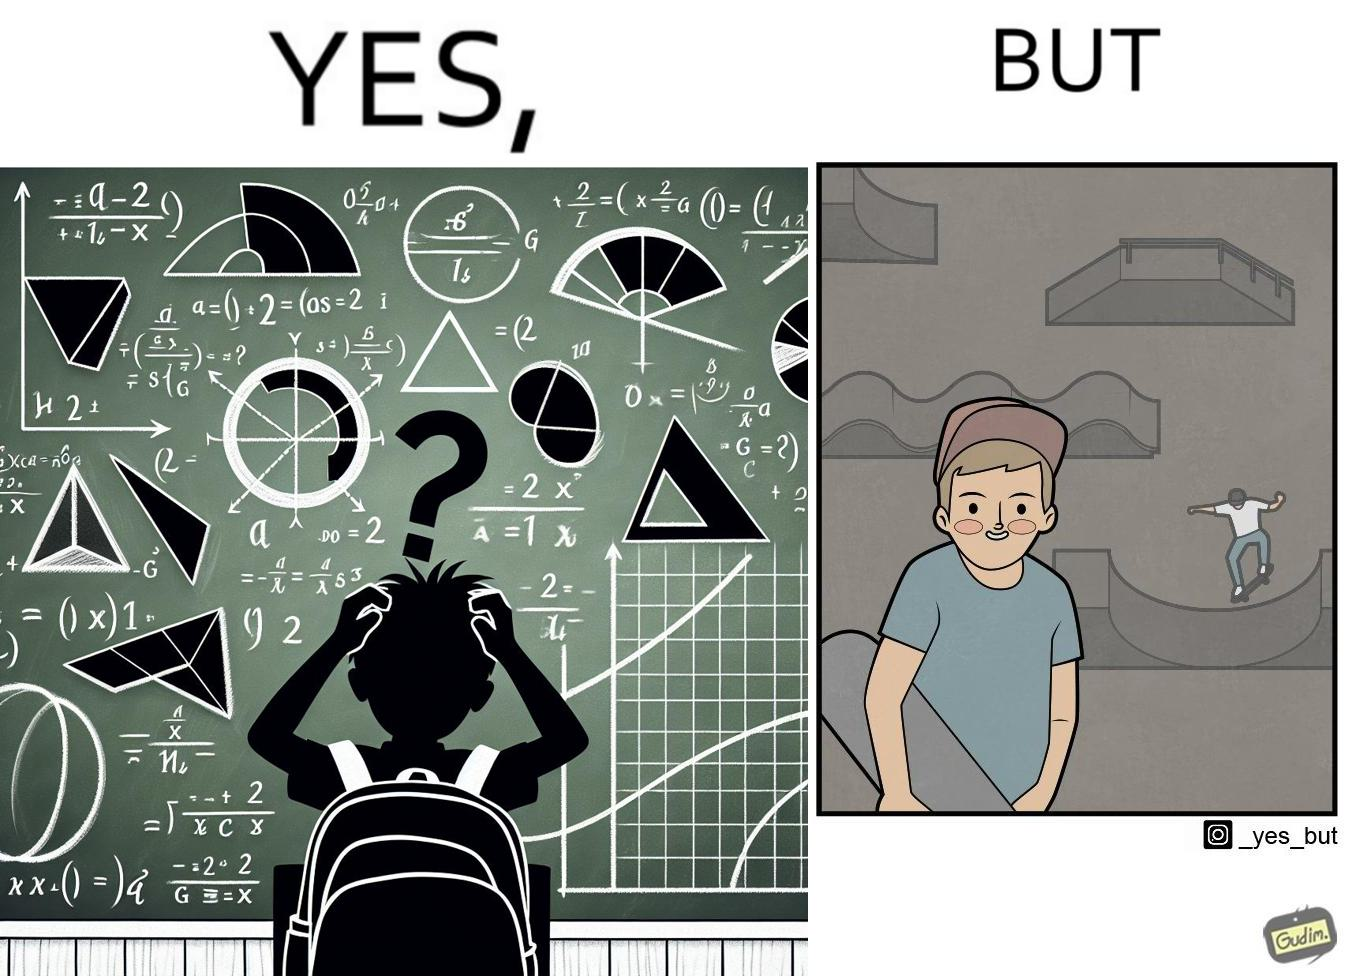Describe what you see in this image. The image is ironical beaucse while the boy does not enjoy studying mathematics and different geometric shapes like semi circle and trapezoid and graphs of trigonometric equations like that of a sine wave, he enjoys skateboarding on surfaces and bowls that are built based on the said geometric shapes and graphs of trigonometric equations. 